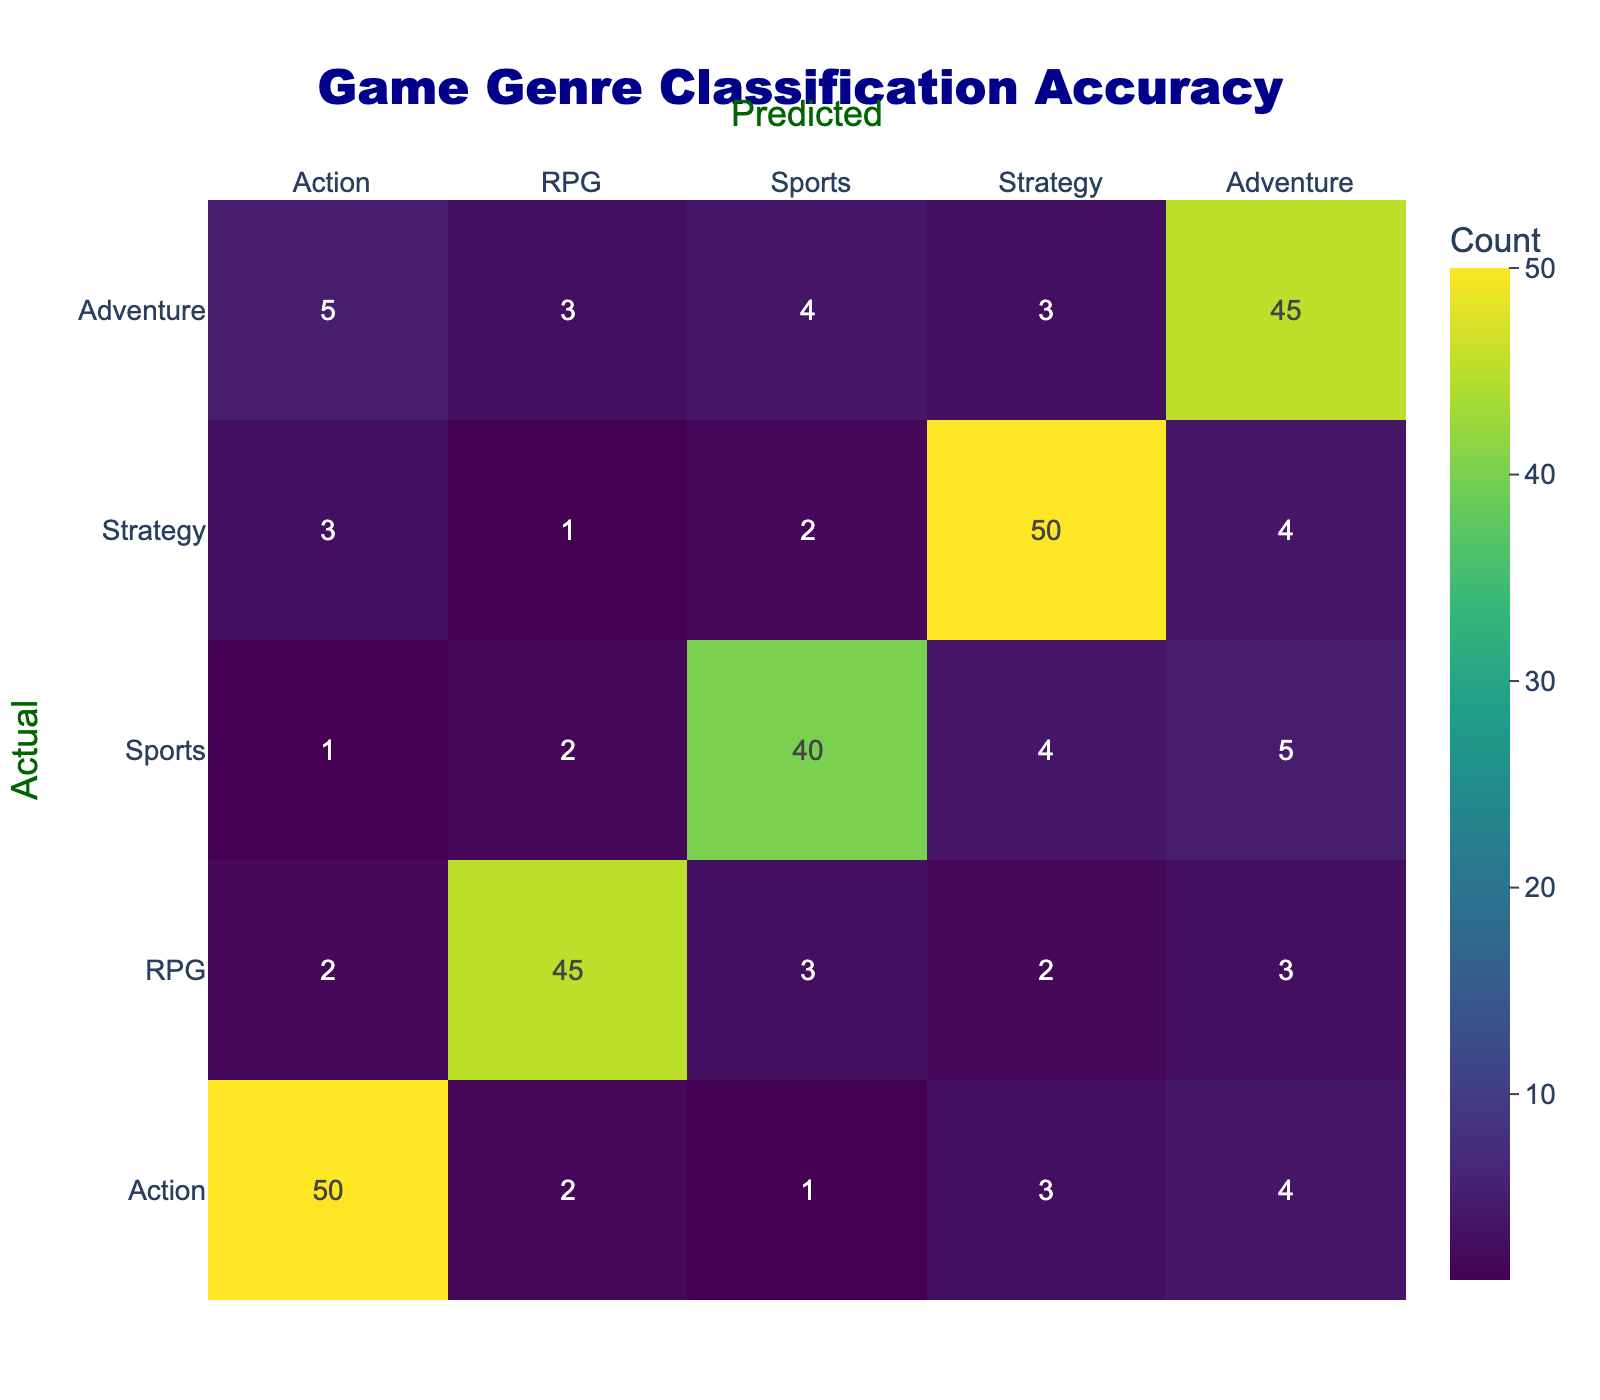What is the predicted genre classification accuracy for Action games? From the table, the count of predicted Action games when the actual genre is Action is 50. Thus, the accuracy for predicted Action games is 50.
Answer: 50 How many Adventure games were incorrectly classified as Strategy? The table shows that when Adventure was the actual genre, 3 were predicted as Strategy. Therefore, 3 Adventure games were incorrectly classified.
Answer: 3 What is the total count of RPG games predicted as other genres? To find this, we sum the numbers in the RPG row excluding the actual RPG value itself: 2 (Action) + 3 (Sports) + 2 (Strategy) + 3 (Adventure) = 10. Thus, the total count of RPG games predicted as other genres is 10.
Answer: 10 Is it true that fewer Sports games were classified as Action than Action games classified as Sports? The count of Sports games classified as Action is 1, while the count of Action games classified as Sports is 3. 1 is less than 3, therefore, the statement is true.
Answer: Yes What is the average misclassification count across all genres? First, we determine the total misclassification counts for each genre: for Action: 2+1+3+4=10, for RPG: 2+3+2+3=10, for Sports: 1+2+4+5=12, for Strategy: 3+1+2+4=10, for Adventure: 5+3+4+3=15. The total misclassifications is 10 + 10 + 12 + 10 + 15 = 57. There are 5 genres, so the average is 57/5 = 11.4.
Answer: 11.4 